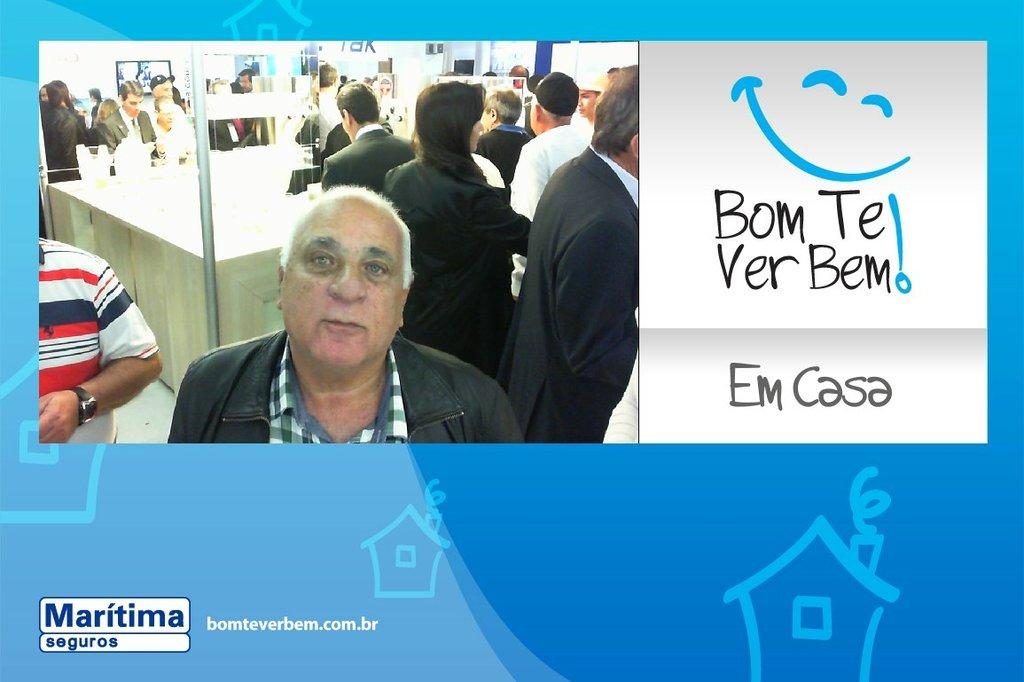<image>
Present a compact description of the photo's key features. Man next to a smiley face sign that says Bom Te Ver Bem! 